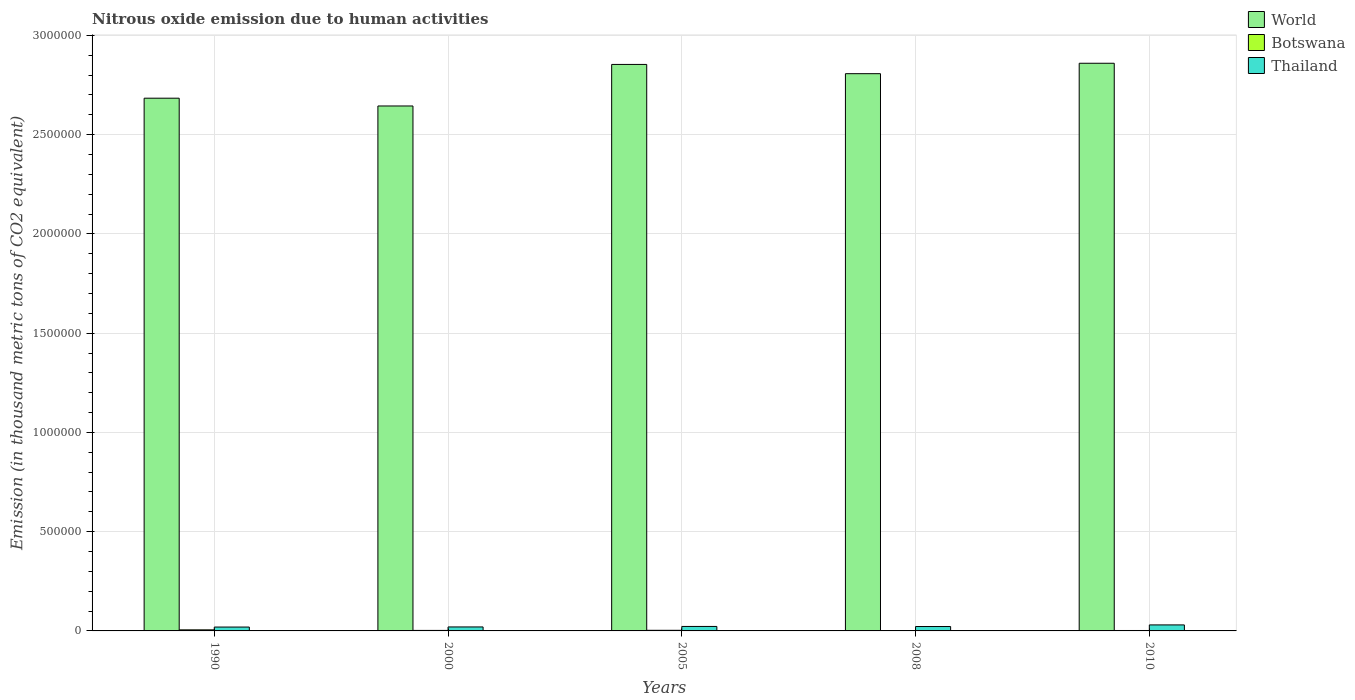How many different coloured bars are there?
Your response must be concise. 3. How many groups of bars are there?
Provide a succinct answer. 5. Are the number of bars per tick equal to the number of legend labels?
Make the answer very short. Yes. Are the number of bars on each tick of the X-axis equal?
Offer a very short reply. Yes. How many bars are there on the 5th tick from the left?
Your answer should be very brief. 3. What is the label of the 2nd group of bars from the left?
Make the answer very short. 2000. What is the amount of nitrous oxide emitted in Botswana in 2000?
Provide a succinct answer. 2523.6. Across all years, what is the maximum amount of nitrous oxide emitted in World?
Keep it short and to the point. 2.86e+06. Across all years, what is the minimum amount of nitrous oxide emitted in Thailand?
Your answer should be very brief. 1.95e+04. In which year was the amount of nitrous oxide emitted in Botswana maximum?
Offer a very short reply. 1990. What is the total amount of nitrous oxide emitted in World in the graph?
Offer a very short reply. 1.38e+07. What is the difference between the amount of nitrous oxide emitted in World in 2005 and that in 2008?
Make the answer very short. 4.66e+04. What is the difference between the amount of nitrous oxide emitted in Thailand in 2008 and the amount of nitrous oxide emitted in Botswana in 2005?
Offer a very short reply. 1.91e+04. What is the average amount of nitrous oxide emitted in World per year?
Your answer should be compact. 2.77e+06. In the year 2005, what is the difference between the amount of nitrous oxide emitted in Botswana and amount of nitrous oxide emitted in Thailand?
Keep it short and to the point. -1.95e+04. In how many years, is the amount of nitrous oxide emitted in Botswana greater than 1700000 thousand metric tons?
Your response must be concise. 0. What is the ratio of the amount of nitrous oxide emitted in World in 2005 to that in 2008?
Your answer should be very brief. 1.02. Is the amount of nitrous oxide emitted in World in 2008 less than that in 2010?
Offer a terse response. Yes. What is the difference between the highest and the second highest amount of nitrous oxide emitted in World?
Offer a very short reply. 5911.5. What is the difference between the highest and the lowest amount of nitrous oxide emitted in Thailand?
Make the answer very short. 1.08e+04. In how many years, is the amount of nitrous oxide emitted in World greater than the average amount of nitrous oxide emitted in World taken over all years?
Make the answer very short. 3. Is it the case that in every year, the sum of the amount of nitrous oxide emitted in Thailand and amount of nitrous oxide emitted in World is greater than the amount of nitrous oxide emitted in Botswana?
Provide a succinct answer. Yes. How many bars are there?
Provide a short and direct response. 15. How many years are there in the graph?
Your answer should be very brief. 5. Does the graph contain any zero values?
Your answer should be compact. No. Does the graph contain grids?
Ensure brevity in your answer.  Yes. How many legend labels are there?
Your response must be concise. 3. What is the title of the graph?
Your answer should be very brief. Nitrous oxide emission due to human activities. Does "Mozambique" appear as one of the legend labels in the graph?
Your answer should be very brief. No. What is the label or title of the Y-axis?
Provide a succinct answer. Emission (in thousand metric tons of CO2 equivalent). What is the Emission (in thousand metric tons of CO2 equivalent) in World in 1990?
Your response must be concise. 2.68e+06. What is the Emission (in thousand metric tons of CO2 equivalent) of Botswana in 1990?
Make the answer very short. 5394.5. What is the Emission (in thousand metric tons of CO2 equivalent) in Thailand in 1990?
Your response must be concise. 1.95e+04. What is the Emission (in thousand metric tons of CO2 equivalent) of World in 2000?
Give a very brief answer. 2.64e+06. What is the Emission (in thousand metric tons of CO2 equivalent) in Botswana in 2000?
Keep it short and to the point. 2523.6. What is the Emission (in thousand metric tons of CO2 equivalent) in Thailand in 2000?
Offer a very short reply. 2.01e+04. What is the Emission (in thousand metric tons of CO2 equivalent) in World in 2005?
Ensure brevity in your answer.  2.85e+06. What is the Emission (in thousand metric tons of CO2 equivalent) of Botswana in 2005?
Make the answer very short. 3096.5. What is the Emission (in thousand metric tons of CO2 equivalent) in Thailand in 2005?
Your answer should be compact. 2.26e+04. What is the Emission (in thousand metric tons of CO2 equivalent) of World in 2008?
Offer a terse response. 2.81e+06. What is the Emission (in thousand metric tons of CO2 equivalent) of Botswana in 2008?
Offer a very short reply. 1998.1. What is the Emission (in thousand metric tons of CO2 equivalent) in Thailand in 2008?
Your answer should be compact. 2.22e+04. What is the Emission (in thousand metric tons of CO2 equivalent) in World in 2010?
Make the answer very short. 2.86e+06. What is the Emission (in thousand metric tons of CO2 equivalent) of Botswana in 2010?
Your answer should be compact. 2184.8. What is the Emission (in thousand metric tons of CO2 equivalent) of Thailand in 2010?
Offer a terse response. 3.02e+04. Across all years, what is the maximum Emission (in thousand metric tons of CO2 equivalent) in World?
Your answer should be compact. 2.86e+06. Across all years, what is the maximum Emission (in thousand metric tons of CO2 equivalent) in Botswana?
Your answer should be compact. 5394.5. Across all years, what is the maximum Emission (in thousand metric tons of CO2 equivalent) of Thailand?
Offer a very short reply. 3.02e+04. Across all years, what is the minimum Emission (in thousand metric tons of CO2 equivalent) of World?
Provide a succinct answer. 2.64e+06. Across all years, what is the minimum Emission (in thousand metric tons of CO2 equivalent) of Botswana?
Make the answer very short. 1998.1. Across all years, what is the minimum Emission (in thousand metric tons of CO2 equivalent) of Thailand?
Provide a short and direct response. 1.95e+04. What is the total Emission (in thousand metric tons of CO2 equivalent) of World in the graph?
Your response must be concise. 1.38e+07. What is the total Emission (in thousand metric tons of CO2 equivalent) of Botswana in the graph?
Your answer should be very brief. 1.52e+04. What is the total Emission (in thousand metric tons of CO2 equivalent) in Thailand in the graph?
Keep it short and to the point. 1.15e+05. What is the difference between the Emission (in thousand metric tons of CO2 equivalent) of World in 1990 and that in 2000?
Your answer should be very brief. 3.92e+04. What is the difference between the Emission (in thousand metric tons of CO2 equivalent) in Botswana in 1990 and that in 2000?
Provide a short and direct response. 2870.9. What is the difference between the Emission (in thousand metric tons of CO2 equivalent) of Thailand in 1990 and that in 2000?
Give a very brief answer. -586.2. What is the difference between the Emission (in thousand metric tons of CO2 equivalent) in World in 1990 and that in 2005?
Make the answer very short. -1.70e+05. What is the difference between the Emission (in thousand metric tons of CO2 equivalent) of Botswana in 1990 and that in 2005?
Keep it short and to the point. 2298. What is the difference between the Emission (in thousand metric tons of CO2 equivalent) of Thailand in 1990 and that in 2005?
Offer a very short reply. -3080.2. What is the difference between the Emission (in thousand metric tons of CO2 equivalent) of World in 1990 and that in 2008?
Offer a terse response. -1.24e+05. What is the difference between the Emission (in thousand metric tons of CO2 equivalent) in Botswana in 1990 and that in 2008?
Your answer should be very brief. 3396.4. What is the difference between the Emission (in thousand metric tons of CO2 equivalent) in Thailand in 1990 and that in 2008?
Make the answer very short. -2680.3. What is the difference between the Emission (in thousand metric tons of CO2 equivalent) in World in 1990 and that in 2010?
Your answer should be compact. -1.76e+05. What is the difference between the Emission (in thousand metric tons of CO2 equivalent) of Botswana in 1990 and that in 2010?
Ensure brevity in your answer.  3209.7. What is the difference between the Emission (in thousand metric tons of CO2 equivalent) of Thailand in 1990 and that in 2010?
Provide a short and direct response. -1.08e+04. What is the difference between the Emission (in thousand metric tons of CO2 equivalent) in World in 2000 and that in 2005?
Provide a short and direct response. -2.09e+05. What is the difference between the Emission (in thousand metric tons of CO2 equivalent) in Botswana in 2000 and that in 2005?
Ensure brevity in your answer.  -572.9. What is the difference between the Emission (in thousand metric tons of CO2 equivalent) in Thailand in 2000 and that in 2005?
Ensure brevity in your answer.  -2494. What is the difference between the Emission (in thousand metric tons of CO2 equivalent) in World in 2000 and that in 2008?
Keep it short and to the point. -1.63e+05. What is the difference between the Emission (in thousand metric tons of CO2 equivalent) of Botswana in 2000 and that in 2008?
Keep it short and to the point. 525.5. What is the difference between the Emission (in thousand metric tons of CO2 equivalent) of Thailand in 2000 and that in 2008?
Your response must be concise. -2094.1. What is the difference between the Emission (in thousand metric tons of CO2 equivalent) in World in 2000 and that in 2010?
Your answer should be compact. -2.15e+05. What is the difference between the Emission (in thousand metric tons of CO2 equivalent) in Botswana in 2000 and that in 2010?
Offer a very short reply. 338.8. What is the difference between the Emission (in thousand metric tons of CO2 equivalent) of Thailand in 2000 and that in 2010?
Offer a terse response. -1.02e+04. What is the difference between the Emission (in thousand metric tons of CO2 equivalent) in World in 2005 and that in 2008?
Provide a succinct answer. 4.66e+04. What is the difference between the Emission (in thousand metric tons of CO2 equivalent) in Botswana in 2005 and that in 2008?
Ensure brevity in your answer.  1098.4. What is the difference between the Emission (in thousand metric tons of CO2 equivalent) of Thailand in 2005 and that in 2008?
Your answer should be compact. 399.9. What is the difference between the Emission (in thousand metric tons of CO2 equivalent) of World in 2005 and that in 2010?
Ensure brevity in your answer.  -5911.5. What is the difference between the Emission (in thousand metric tons of CO2 equivalent) in Botswana in 2005 and that in 2010?
Your response must be concise. 911.7. What is the difference between the Emission (in thousand metric tons of CO2 equivalent) in Thailand in 2005 and that in 2010?
Offer a terse response. -7685.5. What is the difference between the Emission (in thousand metric tons of CO2 equivalent) of World in 2008 and that in 2010?
Ensure brevity in your answer.  -5.25e+04. What is the difference between the Emission (in thousand metric tons of CO2 equivalent) of Botswana in 2008 and that in 2010?
Your answer should be very brief. -186.7. What is the difference between the Emission (in thousand metric tons of CO2 equivalent) of Thailand in 2008 and that in 2010?
Your response must be concise. -8085.4. What is the difference between the Emission (in thousand metric tons of CO2 equivalent) of World in 1990 and the Emission (in thousand metric tons of CO2 equivalent) of Botswana in 2000?
Keep it short and to the point. 2.68e+06. What is the difference between the Emission (in thousand metric tons of CO2 equivalent) of World in 1990 and the Emission (in thousand metric tons of CO2 equivalent) of Thailand in 2000?
Keep it short and to the point. 2.66e+06. What is the difference between the Emission (in thousand metric tons of CO2 equivalent) in Botswana in 1990 and the Emission (in thousand metric tons of CO2 equivalent) in Thailand in 2000?
Your answer should be very brief. -1.47e+04. What is the difference between the Emission (in thousand metric tons of CO2 equivalent) of World in 1990 and the Emission (in thousand metric tons of CO2 equivalent) of Botswana in 2005?
Ensure brevity in your answer.  2.68e+06. What is the difference between the Emission (in thousand metric tons of CO2 equivalent) of World in 1990 and the Emission (in thousand metric tons of CO2 equivalent) of Thailand in 2005?
Your answer should be very brief. 2.66e+06. What is the difference between the Emission (in thousand metric tons of CO2 equivalent) in Botswana in 1990 and the Emission (in thousand metric tons of CO2 equivalent) in Thailand in 2005?
Make the answer very short. -1.72e+04. What is the difference between the Emission (in thousand metric tons of CO2 equivalent) of World in 1990 and the Emission (in thousand metric tons of CO2 equivalent) of Botswana in 2008?
Your response must be concise. 2.68e+06. What is the difference between the Emission (in thousand metric tons of CO2 equivalent) of World in 1990 and the Emission (in thousand metric tons of CO2 equivalent) of Thailand in 2008?
Your answer should be very brief. 2.66e+06. What is the difference between the Emission (in thousand metric tons of CO2 equivalent) in Botswana in 1990 and the Emission (in thousand metric tons of CO2 equivalent) in Thailand in 2008?
Offer a terse response. -1.68e+04. What is the difference between the Emission (in thousand metric tons of CO2 equivalent) of World in 1990 and the Emission (in thousand metric tons of CO2 equivalent) of Botswana in 2010?
Provide a short and direct response. 2.68e+06. What is the difference between the Emission (in thousand metric tons of CO2 equivalent) in World in 1990 and the Emission (in thousand metric tons of CO2 equivalent) in Thailand in 2010?
Offer a terse response. 2.65e+06. What is the difference between the Emission (in thousand metric tons of CO2 equivalent) in Botswana in 1990 and the Emission (in thousand metric tons of CO2 equivalent) in Thailand in 2010?
Make the answer very short. -2.49e+04. What is the difference between the Emission (in thousand metric tons of CO2 equivalent) of World in 2000 and the Emission (in thousand metric tons of CO2 equivalent) of Botswana in 2005?
Provide a short and direct response. 2.64e+06. What is the difference between the Emission (in thousand metric tons of CO2 equivalent) of World in 2000 and the Emission (in thousand metric tons of CO2 equivalent) of Thailand in 2005?
Make the answer very short. 2.62e+06. What is the difference between the Emission (in thousand metric tons of CO2 equivalent) in Botswana in 2000 and the Emission (in thousand metric tons of CO2 equivalent) in Thailand in 2005?
Offer a terse response. -2.00e+04. What is the difference between the Emission (in thousand metric tons of CO2 equivalent) in World in 2000 and the Emission (in thousand metric tons of CO2 equivalent) in Botswana in 2008?
Offer a very short reply. 2.64e+06. What is the difference between the Emission (in thousand metric tons of CO2 equivalent) of World in 2000 and the Emission (in thousand metric tons of CO2 equivalent) of Thailand in 2008?
Your response must be concise. 2.62e+06. What is the difference between the Emission (in thousand metric tons of CO2 equivalent) in Botswana in 2000 and the Emission (in thousand metric tons of CO2 equivalent) in Thailand in 2008?
Your answer should be compact. -1.96e+04. What is the difference between the Emission (in thousand metric tons of CO2 equivalent) in World in 2000 and the Emission (in thousand metric tons of CO2 equivalent) in Botswana in 2010?
Your answer should be very brief. 2.64e+06. What is the difference between the Emission (in thousand metric tons of CO2 equivalent) of World in 2000 and the Emission (in thousand metric tons of CO2 equivalent) of Thailand in 2010?
Your answer should be compact. 2.61e+06. What is the difference between the Emission (in thousand metric tons of CO2 equivalent) in Botswana in 2000 and the Emission (in thousand metric tons of CO2 equivalent) in Thailand in 2010?
Offer a very short reply. -2.77e+04. What is the difference between the Emission (in thousand metric tons of CO2 equivalent) of World in 2005 and the Emission (in thousand metric tons of CO2 equivalent) of Botswana in 2008?
Provide a succinct answer. 2.85e+06. What is the difference between the Emission (in thousand metric tons of CO2 equivalent) in World in 2005 and the Emission (in thousand metric tons of CO2 equivalent) in Thailand in 2008?
Provide a succinct answer. 2.83e+06. What is the difference between the Emission (in thousand metric tons of CO2 equivalent) in Botswana in 2005 and the Emission (in thousand metric tons of CO2 equivalent) in Thailand in 2008?
Offer a very short reply. -1.91e+04. What is the difference between the Emission (in thousand metric tons of CO2 equivalent) in World in 2005 and the Emission (in thousand metric tons of CO2 equivalent) in Botswana in 2010?
Your answer should be compact. 2.85e+06. What is the difference between the Emission (in thousand metric tons of CO2 equivalent) of World in 2005 and the Emission (in thousand metric tons of CO2 equivalent) of Thailand in 2010?
Offer a very short reply. 2.82e+06. What is the difference between the Emission (in thousand metric tons of CO2 equivalent) of Botswana in 2005 and the Emission (in thousand metric tons of CO2 equivalent) of Thailand in 2010?
Provide a short and direct response. -2.71e+04. What is the difference between the Emission (in thousand metric tons of CO2 equivalent) of World in 2008 and the Emission (in thousand metric tons of CO2 equivalent) of Botswana in 2010?
Keep it short and to the point. 2.81e+06. What is the difference between the Emission (in thousand metric tons of CO2 equivalent) in World in 2008 and the Emission (in thousand metric tons of CO2 equivalent) in Thailand in 2010?
Offer a very short reply. 2.78e+06. What is the difference between the Emission (in thousand metric tons of CO2 equivalent) in Botswana in 2008 and the Emission (in thousand metric tons of CO2 equivalent) in Thailand in 2010?
Make the answer very short. -2.82e+04. What is the average Emission (in thousand metric tons of CO2 equivalent) in World per year?
Your answer should be compact. 2.77e+06. What is the average Emission (in thousand metric tons of CO2 equivalent) of Botswana per year?
Offer a very short reply. 3039.5. What is the average Emission (in thousand metric tons of CO2 equivalent) of Thailand per year?
Give a very brief answer. 2.29e+04. In the year 1990, what is the difference between the Emission (in thousand metric tons of CO2 equivalent) in World and Emission (in thousand metric tons of CO2 equivalent) in Botswana?
Ensure brevity in your answer.  2.68e+06. In the year 1990, what is the difference between the Emission (in thousand metric tons of CO2 equivalent) in World and Emission (in thousand metric tons of CO2 equivalent) in Thailand?
Offer a terse response. 2.66e+06. In the year 1990, what is the difference between the Emission (in thousand metric tons of CO2 equivalent) of Botswana and Emission (in thousand metric tons of CO2 equivalent) of Thailand?
Provide a short and direct response. -1.41e+04. In the year 2000, what is the difference between the Emission (in thousand metric tons of CO2 equivalent) of World and Emission (in thousand metric tons of CO2 equivalent) of Botswana?
Offer a very short reply. 2.64e+06. In the year 2000, what is the difference between the Emission (in thousand metric tons of CO2 equivalent) in World and Emission (in thousand metric tons of CO2 equivalent) in Thailand?
Your answer should be compact. 2.62e+06. In the year 2000, what is the difference between the Emission (in thousand metric tons of CO2 equivalent) in Botswana and Emission (in thousand metric tons of CO2 equivalent) in Thailand?
Your response must be concise. -1.75e+04. In the year 2005, what is the difference between the Emission (in thousand metric tons of CO2 equivalent) in World and Emission (in thousand metric tons of CO2 equivalent) in Botswana?
Offer a very short reply. 2.85e+06. In the year 2005, what is the difference between the Emission (in thousand metric tons of CO2 equivalent) in World and Emission (in thousand metric tons of CO2 equivalent) in Thailand?
Provide a short and direct response. 2.83e+06. In the year 2005, what is the difference between the Emission (in thousand metric tons of CO2 equivalent) of Botswana and Emission (in thousand metric tons of CO2 equivalent) of Thailand?
Your answer should be very brief. -1.95e+04. In the year 2008, what is the difference between the Emission (in thousand metric tons of CO2 equivalent) in World and Emission (in thousand metric tons of CO2 equivalent) in Botswana?
Make the answer very short. 2.81e+06. In the year 2008, what is the difference between the Emission (in thousand metric tons of CO2 equivalent) in World and Emission (in thousand metric tons of CO2 equivalent) in Thailand?
Make the answer very short. 2.79e+06. In the year 2008, what is the difference between the Emission (in thousand metric tons of CO2 equivalent) in Botswana and Emission (in thousand metric tons of CO2 equivalent) in Thailand?
Offer a terse response. -2.02e+04. In the year 2010, what is the difference between the Emission (in thousand metric tons of CO2 equivalent) of World and Emission (in thousand metric tons of CO2 equivalent) of Botswana?
Ensure brevity in your answer.  2.86e+06. In the year 2010, what is the difference between the Emission (in thousand metric tons of CO2 equivalent) in World and Emission (in thousand metric tons of CO2 equivalent) in Thailand?
Give a very brief answer. 2.83e+06. In the year 2010, what is the difference between the Emission (in thousand metric tons of CO2 equivalent) of Botswana and Emission (in thousand metric tons of CO2 equivalent) of Thailand?
Offer a very short reply. -2.81e+04. What is the ratio of the Emission (in thousand metric tons of CO2 equivalent) of World in 1990 to that in 2000?
Keep it short and to the point. 1.01. What is the ratio of the Emission (in thousand metric tons of CO2 equivalent) of Botswana in 1990 to that in 2000?
Offer a very short reply. 2.14. What is the ratio of the Emission (in thousand metric tons of CO2 equivalent) in Thailand in 1990 to that in 2000?
Offer a terse response. 0.97. What is the ratio of the Emission (in thousand metric tons of CO2 equivalent) of World in 1990 to that in 2005?
Your answer should be compact. 0.94. What is the ratio of the Emission (in thousand metric tons of CO2 equivalent) in Botswana in 1990 to that in 2005?
Ensure brevity in your answer.  1.74. What is the ratio of the Emission (in thousand metric tons of CO2 equivalent) in Thailand in 1990 to that in 2005?
Offer a very short reply. 0.86. What is the ratio of the Emission (in thousand metric tons of CO2 equivalent) in World in 1990 to that in 2008?
Give a very brief answer. 0.96. What is the ratio of the Emission (in thousand metric tons of CO2 equivalent) in Botswana in 1990 to that in 2008?
Keep it short and to the point. 2.7. What is the ratio of the Emission (in thousand metric tons of CO2 equivalent) of Thailand in 1990 to that in 2008?
Your answer should be compact. 0.88. What is the ratio of the Emission (in thousand metric tons of CO2 equivalent) in World in 1990 to that in 2010?
Your answer should be compact. 0.94. What is the ratio of the Emission (in thousand metric tons of CO2 equivalent) of Botswana in 1990 to that in 2010?
Offer a very short reply. 2.47. What is the ratio of the Emission (in thousand metric tons of CO2 equivalent) of Thailand in 1990 to that in 2010?
Your answer should be very brief. 0.64. What is the ratio of the Emission (in thousand metric tons of CO2 equivalent) in World in 2000 to that in 2005?
Keep it short and to the point. 0.93. What is the ratio of the Emission (in thousand metric tons of CO2 equivalent) in Botswana in 2000 to that in 2005?
Offer a terse response. 0.81. What is the ratio of the Emission (in thousand metric tons of CO2 equivalent) in Thailand in 2000 to that in 2005?
Offer a terse response. 0.89. What is the ratio of the Emission (in thousand metric tons of CO2 equivalent) in World in 2000 to that in 2008?
Your answer should be compact. 0.94. What is the ratio of the Emission (in thousand metric tons of CO2 equivalent) in Botswana in 2000 to that in 2008?
Give a very brief answer. 1.26. What is the ratio of the Emission (in thousand metric tons of CO2 equivalent) in Thailand in 2000 to that in 2008?
Ensure brevity in your answer.  0.91. What is the ratio of the Emission (in thousand metric tons of CO2 equivalent) in World in 2000 to that in 2010?
Offer a very short reply. 0.92. What is the ratio of the Emission (in thousand metric tons of CO2 equivalent) of Botswana in 2000 to that in 2010?
Your answer should be very brief. 1.16. What is the ratio of the Emission (in thousand metric tons of CO2 equivalent) in Thailand in 2000 to that in 2010?
Provide a short and direct response. 0.66. What is the ratio of the Emission (in thousand metric tons of CO2 equivalent) in World in 2005 to that in 2008?
Provide a succinct answer. 1.02. What is the ratio of the Emission (in thousand metric tons of CO2 equivalent) in Botswana in 2005 to that in 2008?
Your answer should be very brief. 1.55. What is the ratio of the Emission (in thousand metric tons of CO2 equivalent) of Botswana in 2005 to that in 2010?
Ensure brevity in your answer.  1.42. What is the ratio of the Emission (in thousand metric tons of CO2 equivalent) of Thailand in 2005 to that in 2010?
Your answer should be very brief. 0.75. What is the ratio of the Emission (in thousand metric tons of CO2 equivalent) in World in 2008 to that in 2010?
Provide a succinct answer. 0.98. What is the ratio of the Emission (in thousand metric tons of CO2 equivalent) in Botswana in 2008 to that in 2010?
Offer a very short reply. 0.91. What is the ratio of the Emission (in thousand metric tons of CO2 equivalent) of Thailand in 2008 to that in 2010?
Offer a very short reply. 0.73. What is the difference between the highest and the second highest Emission (in thousand metric tons of CO2 equivalent) in World?
Give a very brief answer. 5911.5. What is the difference between the highest and the second highest Emission (in thousand metric tons of CO2 equivalent) of Botswana?
Ensure brevity in your answer.  2298. What is the difference between the highest and the second highest Emission (in thousand metric tons of CO2 equivalent) of Thailand?
Offer a very short reply. 7685.5. What is the difference between the highest and the lowest Emission (in thousand metric tons of CO2 equivalent) of World?
Provide a succinct answer. 2.15e+05. What is the difference between the highest and the lowest Emission (in thousand metric tons of CO2 equivalent) in Botswana?
Ensure brevity in your answer.  3396.4. What is the difference between the highest and the lowest Emission (in thousand metric tons of CO2 equivalent) in Thailand?
Ensure brevity in your answer.  1.08e+04. 